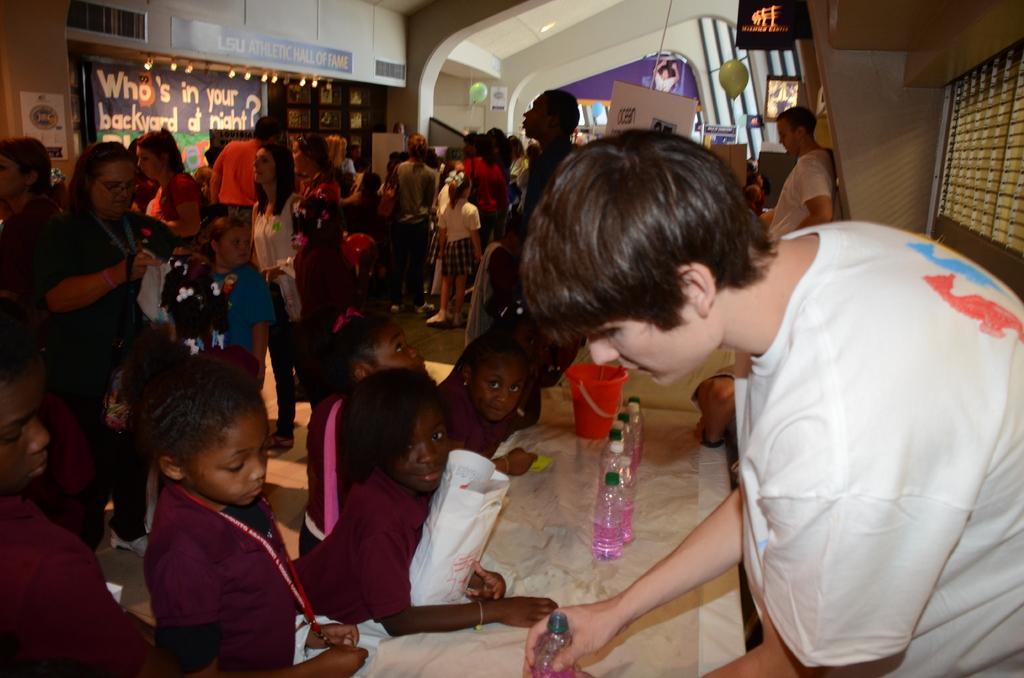Please provide a concise description of this image. Here people are standing, this is cover and bucket, here there are bottles, there is poster on the wall. 